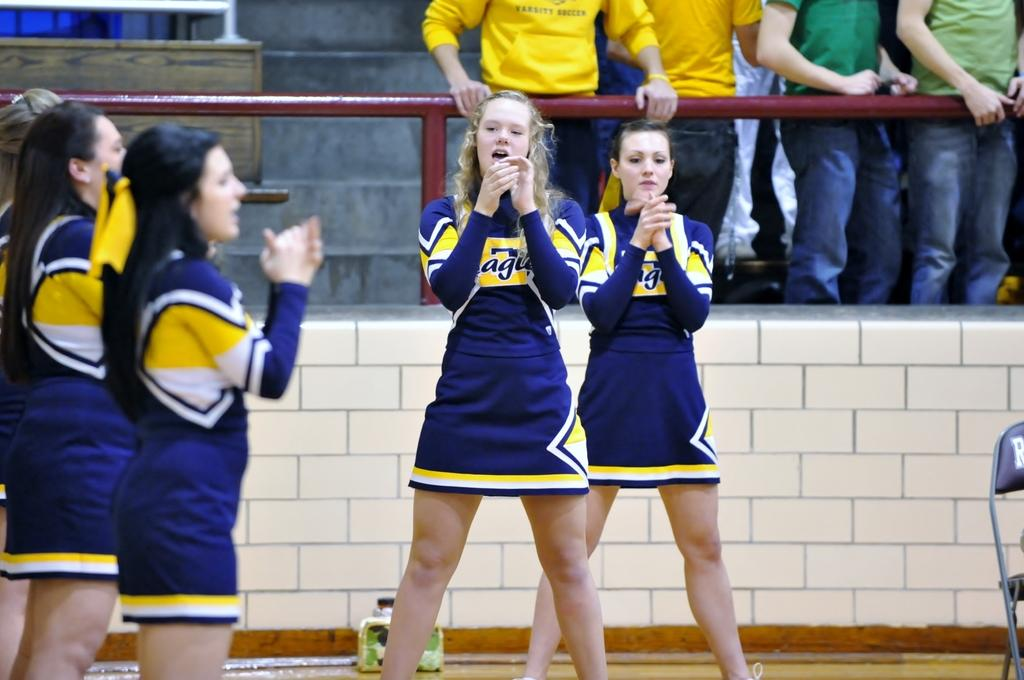<image>
Render a clear and concise summary of the photo. Women in cheer leading outfits that have the partial word agu on them. 